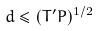<formula> <loc_0><loc_0><loc_500><loc_500>d \leq ( T ^ { \prime } P ) ^ { 1 / 2 }</formula> 